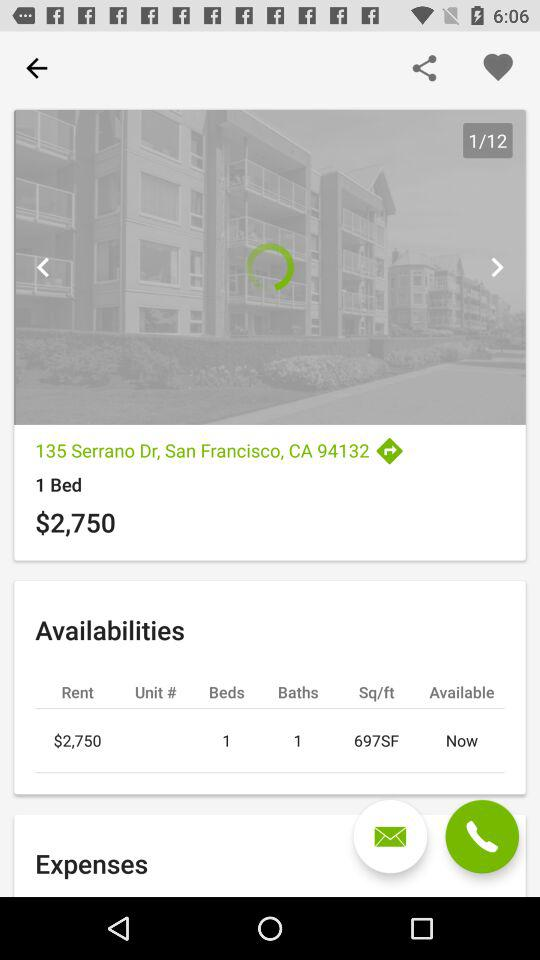What is the total number of images? The total number of images is 12. 